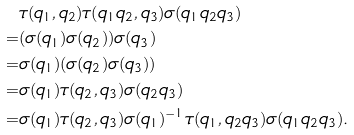Convert formula to latex. <formula><loc_0><loc_0><loc_500><loc_500>& \tau ( q _ { 1 } , q _ { 2 } ) \tau ( q _ { 1 } q _ { 2 } , q _ { 3 } ) \sigma ( q _ { 1 } q _ { 2 } q _ { 3 } ) \\ = & ( \sigma ( q _ { 1 } ) \sigma ( q _ { 2 } ) ) \sigma ( q _ { 3 } ) \\ = & \sigma ( q _ { 1 } ) ( \sigma ( q _ { 2 } ) \sigma ( q _ { 3 } ) ) \\ = & \sigma ( q _ { 1 } ) \tau ( q _ { 2 } , q _ { 3 } ) \sigma ( q _ { 2 } q _ { 3 } ) \\ = & \sigma ( q _ { 1 } ) \tau ( q _ { 2 } , q _ { 3 } ) \sigma ( q _ { 1 } ) ^ { - 1 } \tau ( q _ { 1 } , q _ { 2 } q _ { 3 } ) \sigma ( q _ { 1 } q _ { 2 } q _ { 3 } ) .</formula> 